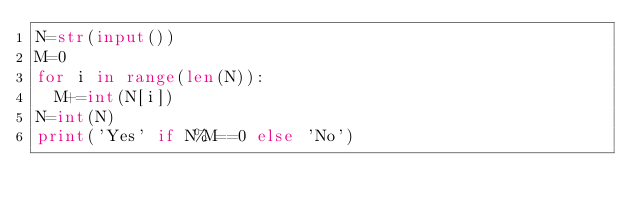<code> <loc_0><loc_0><loc_500><loc_500><_Python_>N=str(input())
M=0
for i in range(len(N)):
  M+=int(N[i])
N=int(N)
print('Yes' if N%M==0 else 'No')</code> 